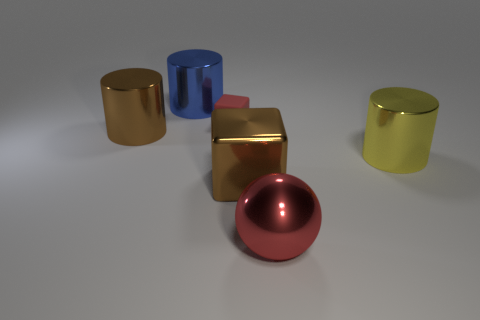Add 1 big cyan blocks. How many objects exist? 7 Subtract all blocks. How many objects are left? 4 Subtract all blue cylinders. How many cylinders are left? 2 Subtract all green balls. Subtract all purple blocks. How many balls are left? 1 Subtract all blue spheres. How many brown cylinders are left? 1 Subtract all blue cylinders. Subtract all tiny brown shiny cubes. How many objects are left? 5 Add 6 brown metal cubes. How many brown metal cubes are left? 7 Add 2 yellow metallic blocks. How many yellow metallic blocks exist? 2 Subtract 0 gray blocks. How many objects are left? 6 Subtract 1 cylinders. How many cylinders are left? 2 